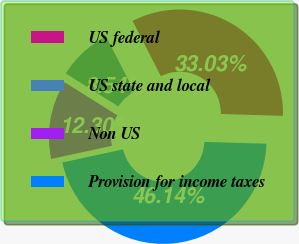<chart> <loc_0><loc_0><loc_500><loc_500><pie_chart><fcel>US federal<fcel>US state and local<fcel>Non US<fcel>Provision for income taxes<nl><fcel>33.03%<fcel>8.54%<fcel>12.3%<fcel>46.14%<nl></chart> 